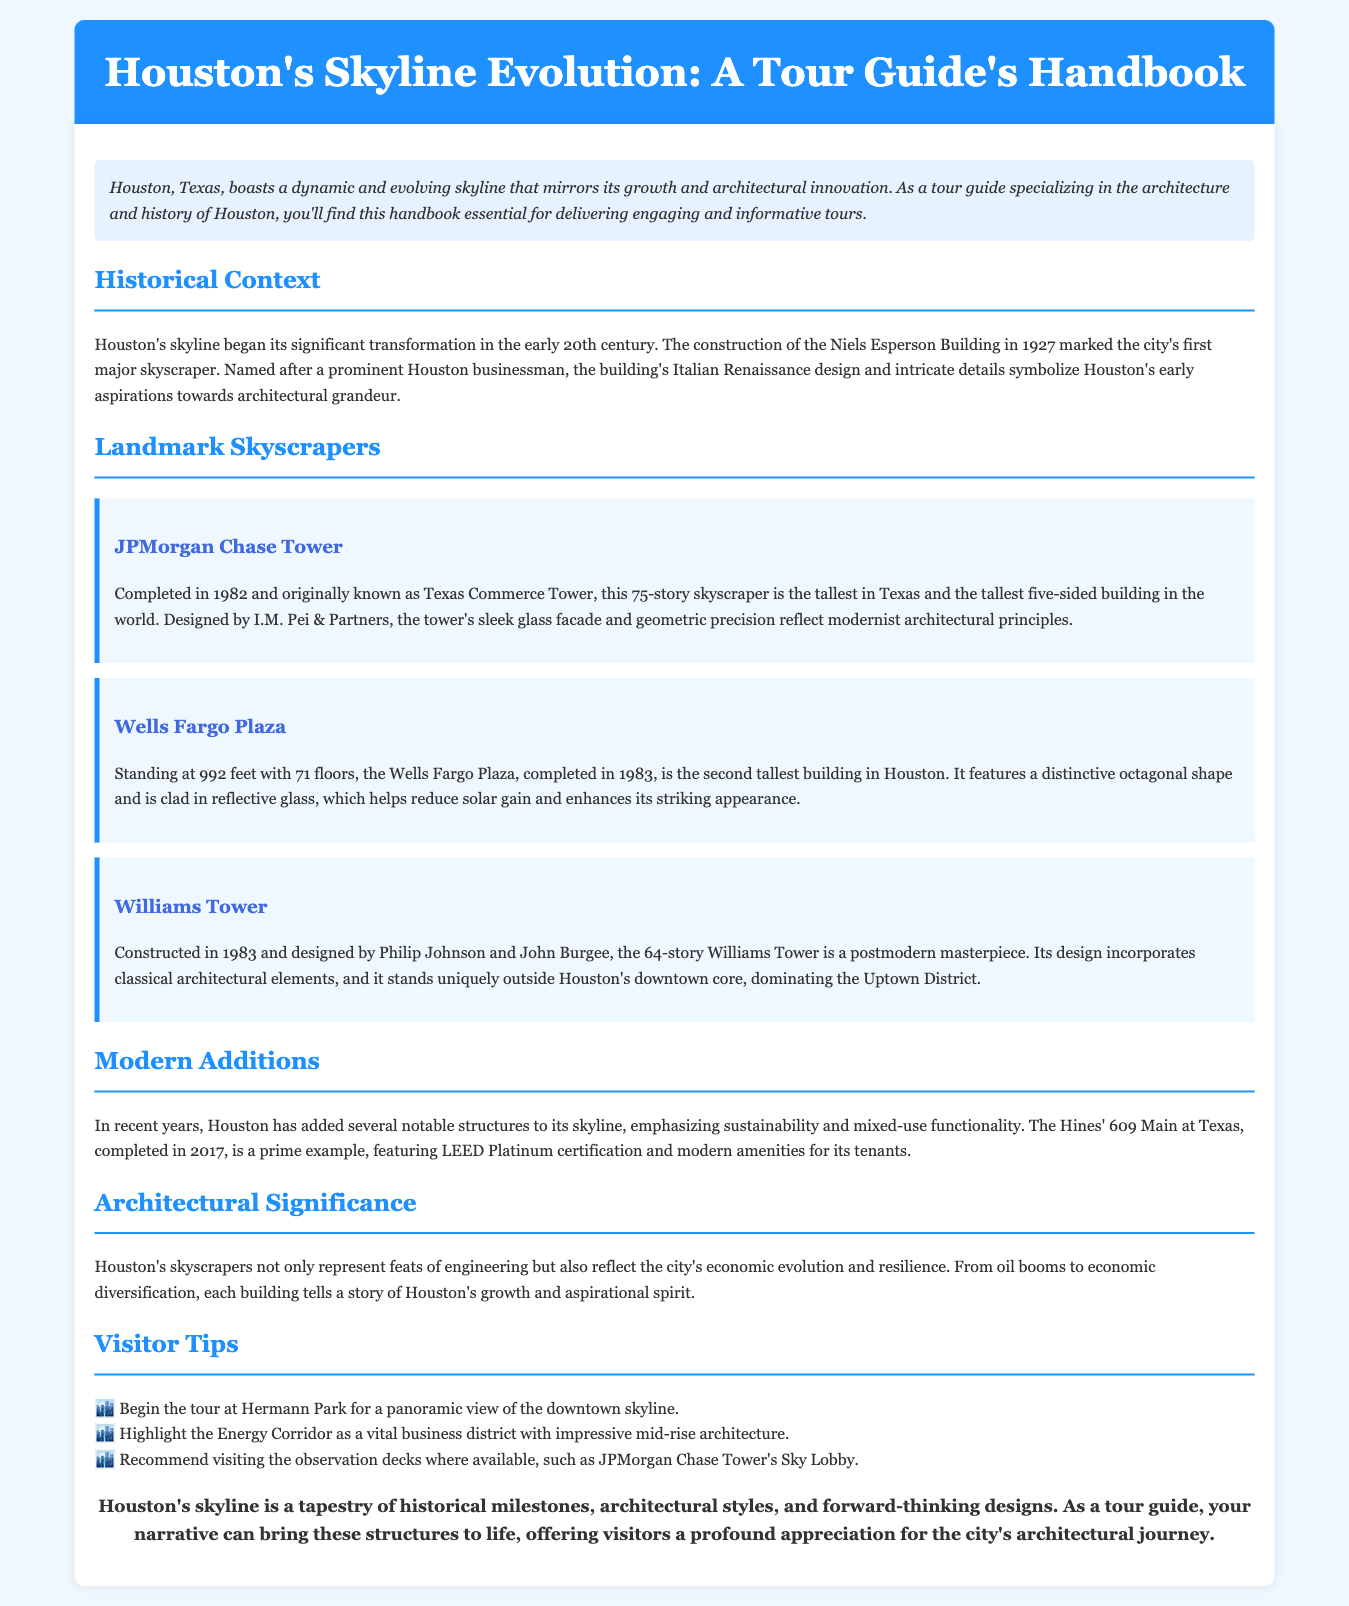What year was the Niels Esperson Building completed? The Niels Esperson Building was completed in 1927, marking Houston's first major skyscraper.
Answer: 1927 How tall is the JPMorgan Chase Tower? The JPMorgan Chase Tower is the tallest in Texas, consisting of 75 stories.
Answer: 75 stories Who designed the Williams Tower? The Williams Tower was designed by Philip Johnson and John Burgee.
Answer: Philip Johnson and John Burgee What is the height of Wells Fargo Plaza? The Wells Fargo Plaza stands at 992 feet tall.
Answer: 992 feet What certification does 609 Main at Texas hold? 609 Main at Texas features LEED Platinum certification, emphasizing sustainability.
Answer: LEED Platinum What architectural style does the JPMorgan Chase Tower reflect? The tower's design reflects modernist architectural principles.
Answer: Modernist What is a recommended starting point for the tour? Beginning the tour at Hermann Park is recommended for a panoramic view.
Answer: Hermann Park What type of design does Williams Tower incorporate? Williams Tower incorporates classical architectural elements in its postmodern design.
Answer: Classical architectural elements 